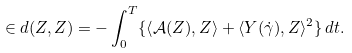<formula> <loc_0><loc_0><loc_500><loc_500>\in d ( Z , Z ) = - \int _ { 0 } ^ { T } \{ \left \langle { \mathcal { A } } ( Z ) , Z \right \rangle + \langle Y ( \dot { \gamma } ) , Z \rangle ^ { 2 } \} \, d t .</formula> 